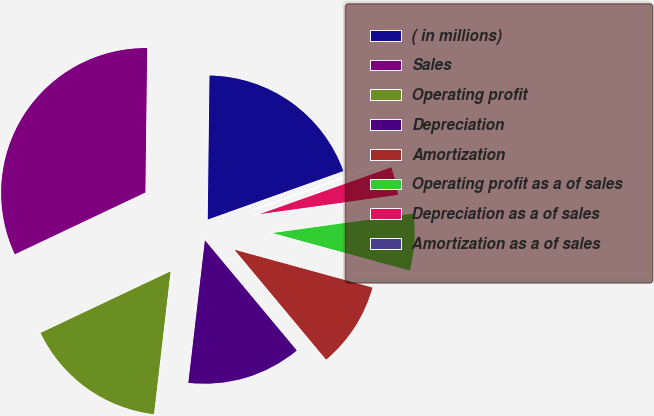<chart> <loc_0><loc_0><loc_500><loc_500><pie_chart><fcel>( in millions)<fcel>Sales<fcel>Operating profit<fcel>Depreciation<fcel>Amortization<fcel>Operating profit as a of sales<fcel>Depreciation as a of sales<fcel>Amortization as a of sales<nl><fcel>19.34%<fcel>32.23%<fcel>16.12%<fcel>12.9%<fcel>9.68%<fcel>6.46%<fcel>3.24%<fcel>0.02%<nl></chart> 